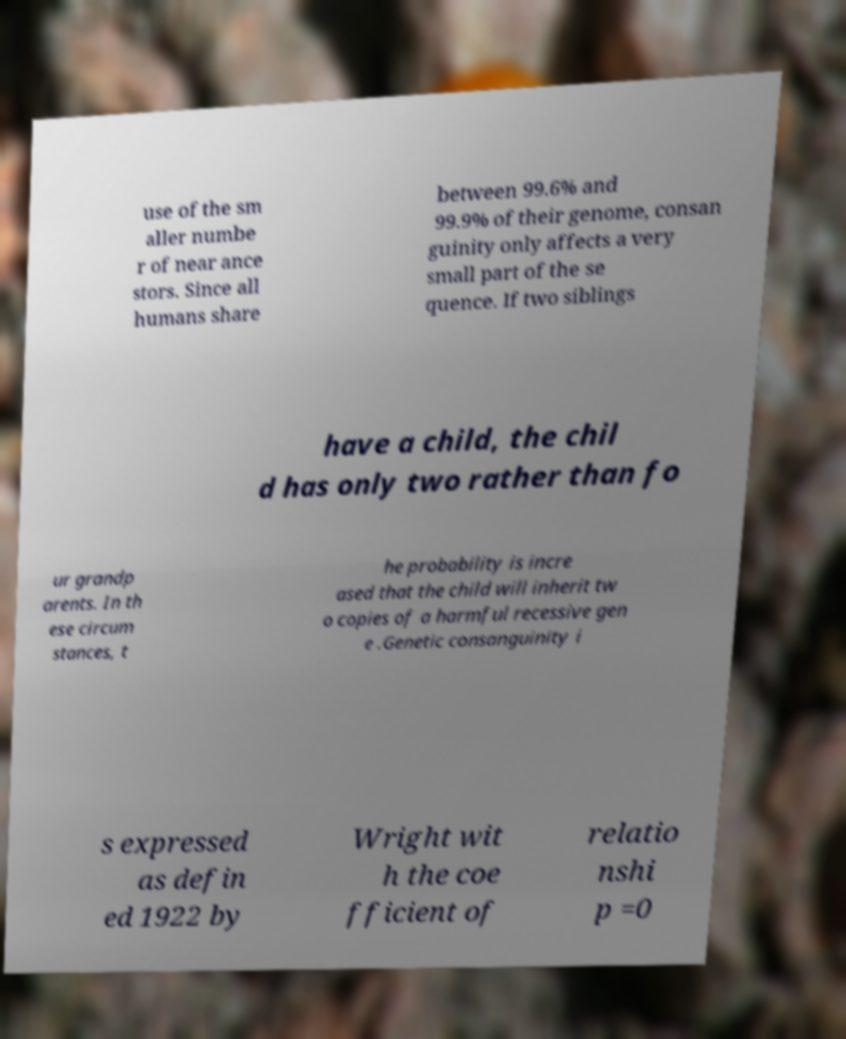There's text embedded in this image that I need extracted. Can you transcribe it verbatim? use of the sm aller numbe r of near ance stors. Since all humans share between 99.6% and 99.9% of their genome, consan guinity only affects a very small part of the se quence. If two siblings have a child, the chil d has only two rather than fo ur grandp arents. In th ese circum stances, t he probability is incre ased that the child will inherit tw o copies of a harmful recessive gen e .Genetic consanguinity i s expressed as defin ed 1922 by Wright wit h the coe fficient of relatio nshi p =0 